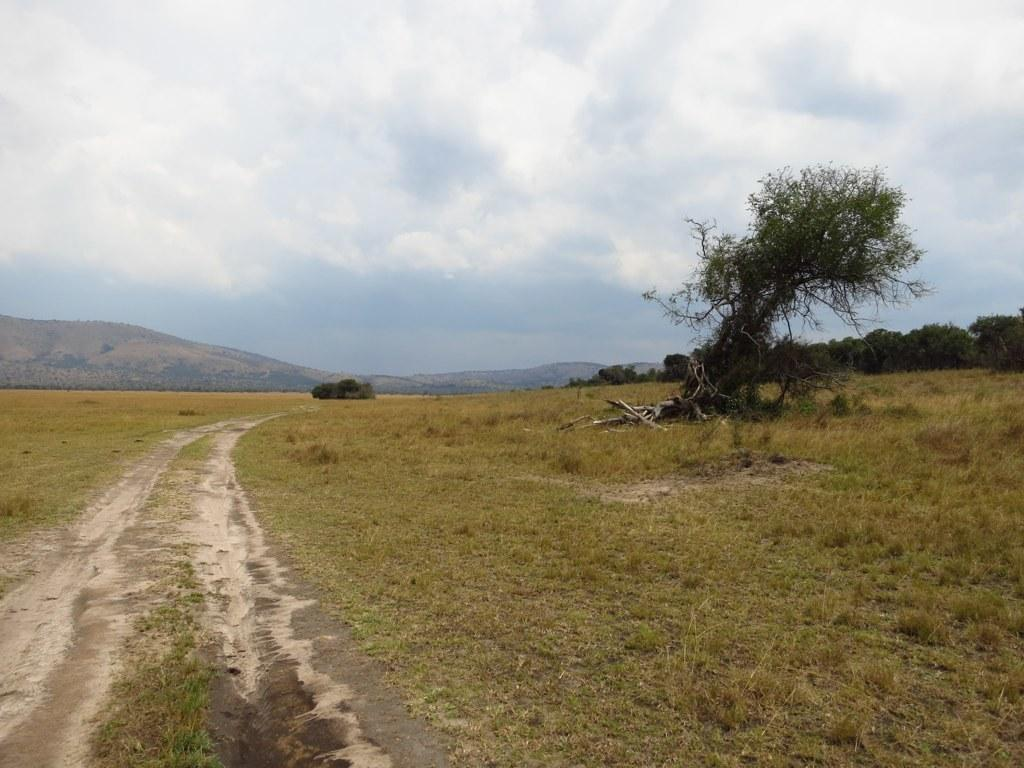What type of vegetation is in the front of the image? There is dry grass in the front of the image. What is located in the center of the image? There is a tree in the center of the image. What can be seen in the background of the image? There are mountains and trees in the background of the image. What is the condition of the sky in the image? The sky is cloudy in the image. How does the bucket express its feelings of hate in the image? There is no bucket present in the image, and therefore no such expression of hate can be observed. What type of range is visible in the image? There is no range present in the image; it features dry grass, a tree, mountains, and trees. 